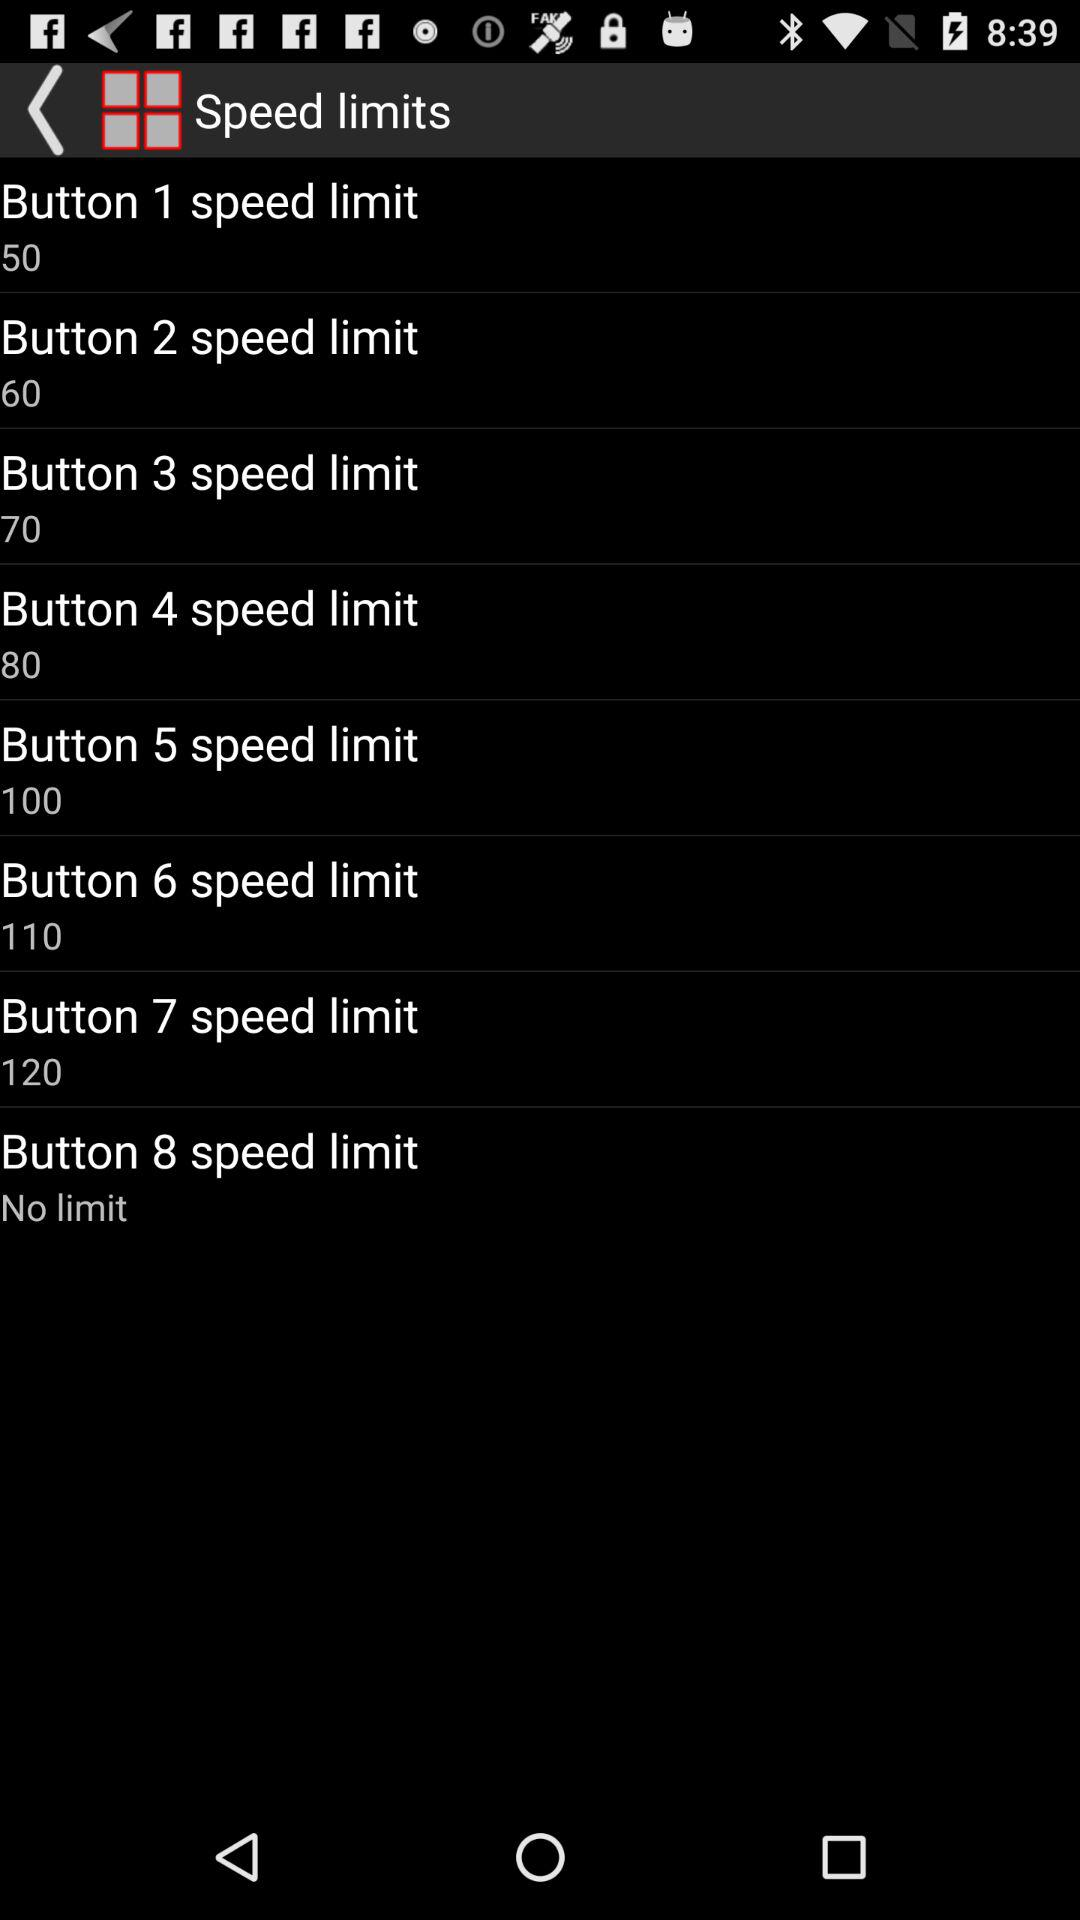What is the difference between the highest and lowest speed limits?
Answer the question using a single word or phrase. 70 